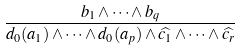Convert formula to latex. <formula><loc_0><loc_0><loc_500><loc_500>\frac { b _ { 1 } \wedge \dots \wedge b _ { q } } { d _ { 0 } ( a _ { 1 } ) \wedge \dots \wedge d _ { 0 } ( a _ { p } ) \wedge \widehat { c _ { 1 } } \wedge \dots \wedge \widehat { c _ { r } } }</formula> 